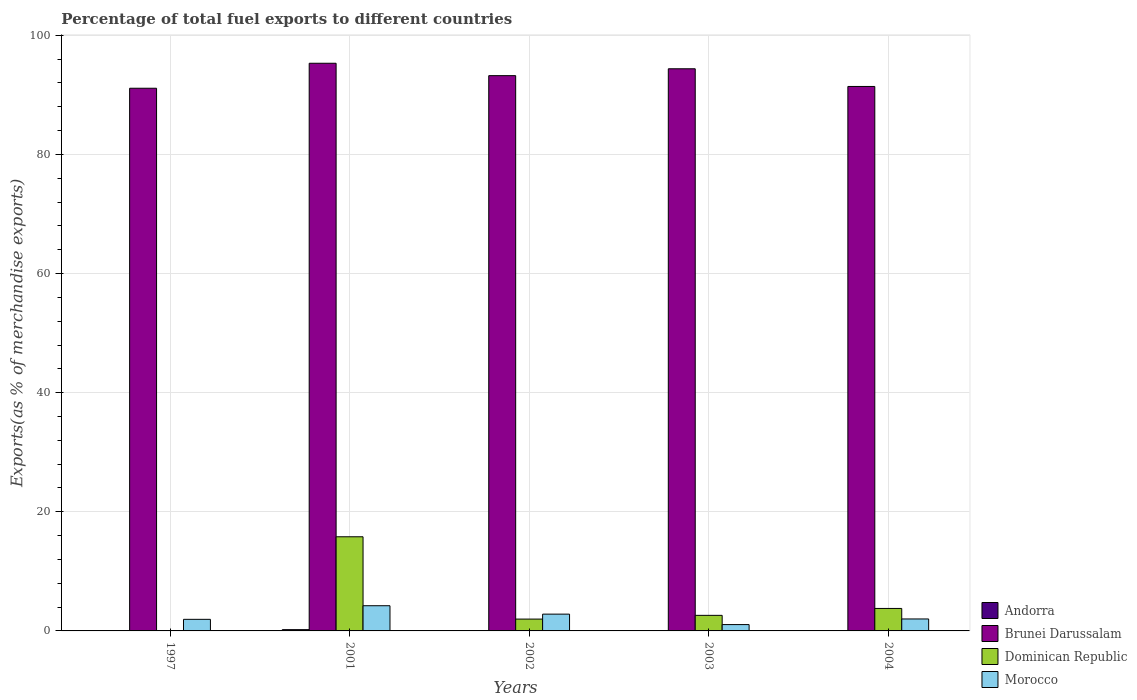How many different coloured bars are there?
Your answer should be compact. 4. Are the number of bars per tick equal to the number of legend labels?
Give a very brief answer. Yes. How many bars are there on the 4th tick from the left?
Your answer should be compact. 4. How many bars are there on the 1st tick from the right?
Your answer should be very brief. 4. What is the label of the 1st group of bars from the left?
Your answer should be very brief. 1997. What is the percentage of exports to different countries in Brunei Darussalam in 2002?
Keep it short and to the point. 93.23. Across all years, what is the maximum percentage of exports to different countries in Morocco?
Your answer should be very brief. 4.23. Across all years, what is the minimum percentage of exports to different countries in Andorra?
Your answer should be very brief. 0. In which year was the percentage of exports to different countries in Brunei Darussalam maximum?
Your response must be concise. 2001. What is the total percentage of exports to different countries in Morocco in the graph?
Your answer should be compact. 12.06. What is the difference between the percentage of exports to different countries in Andorra in 2001 and that in 2003?
Give a very brief answer. 0.21. What is the difference between the percentage of exports to different countries in Morocco in 1997 and the percentage of exports to different countries in Andorra in 2002?
Provide a short and direct response. 1.94. What is the average percentage of exports to different countries in Dominican Republic per year?
Your response must be concise. 4.84. In the year 2003, what is the difference between the percentage of exports to different countries in Andorra and percentage of exports to different countries in Dominican Republic?
Keep it short and to the point. -2.61. What is the ratio of the percentage of exports to different countries in Morocco in 2001 to that in 2004?
Your answer should be compact. 2.11. Is the percentage of exports to different countries in Morocco in 2001 less than that in 2002?
Ensure brevity in your answer.  No. Is the difference between the percentage of exports to different countries in Andorra in 2003 and 2004 greater than the difference between the percentage of exports to different countries in Dominican Republic in 2003 and 2004?
Your response must be concise. Yes. What is the difference between the highest and the second highest percentage of exports to different countries in Brunei Darussalam?
Make the answer very short. 0.92. What is the difference between the highest and the lowest percentage of exports to different countries in Dominican Republic?
Provide a succinct answer. 15.79. In how many years, is the percentage of exports to different countries in Andorra greater than the average percentage of exports to different countries in Andorra taken over all years?
Offer a very short reply. 1. Is it the case that in every year, the sum of the percentage of exports to different countries in Andorra and percentage of exports to different countries in Dominican Republic is greater than the sum of percentage of exports to different countries in Brunei Darussalam and percentage of exports to different countries in Morocco?
Keep it short and to the point. No. What does the 2nd bar from the left in 2002 represents?
Provide a short and direct response. Brunei Darussalam. What does the 4th bar from the right in 2004 represents?
Provide a short and direct response. Andorra. How many years are there in the graph?
Your response must be concise. 5. What is the difference between two consecutive major ticks on the Y-axis?
Ensure brevity in your answer.  20. Are the values on the major ticks of Y-axis written in scientific E-notation?
Provide a succinct answer. No. Does the graph contain any zero values?
Your answer should be compact. No. Does the graph contain grids?
Your response must be concise. Yes. Where does the legend appear in the graph?
Offer a very short reply. Bottom right. What is the title of the graph?
Give a very brief answer. Percentage of total fuel exports to different countries. What is the label or title of the X-axis?
Give a very brief answer. Years. What is the label or title of the Y-axis?
Your answer should be compact. Exports(as % of merchandise exports). What is the Exports(as % of merchandise exports) of Andorra in 1997?
Offer a very short reply. 0.01. What is the Exports(as % of merchandise exports) in Brunei Darussalam in 1997?
Offer a terse response. 91.11. What is the Exports(as % of merchandise exports) in Dominican Republic in 1997?
Ensure brevity in your answer.  0.02. What is the Exports(as % of merchandise exports) in Morocco in 1997?
Make the answer very short. 1.94. What is the Exports(as % of merchandise exports) in Andorra in 2001?
Provide a succinct answer. 0.21. What is the Exports(as % of merchandise exports) of Brunei Darussalam in 2001?
Make the answer very short. 95.31. What is the Exports(as % of merchandise exports) in Dominican Republic in 2001?
Give a very brief answer. 15.81. What is the Exports(as % of merchandise exports) in Morocco in 2001?
Offer a terse response. 4.23. What is the Exports(as % of merchandise exports) in Andorra in 2002?
Make the answer very short. 0. What is the Exports(as % of merchandise exports) of Brunei Darussalam in 2002?
Ensure brevity in your answer.  93.23. What is the Exports(as % of merchandise exports) in Dominican Republic in 2002?
Ensure brevity in your answer.  1.99. What is the Exports(as % of merchandise exports) of Morocco in 2002?
Provide a succinct answer. 2.82. What is the Exports(as % of merchandise exports) of Andorra in 2003?
Ensure brevity in your answer.  0.01. What is the Exports(as % of merchandise exports) of Brunei Darussalam in 2003?
Make the answer very short. 94.38. What is the Exports(as % of merchandise exports) of Dominican Republic in 2003?
Your answer should be compact. 2.61. What is the Exports(as % of merchandise exports) in Morocco in 2003?
Provide a succinct answer. 1.06. What is the Exports(as % of merchandise exports) in Andorra in 2004?
Your answer should be very brief. 0. What is the Exports(as % of merchandise exports) of Brunei Darussalam in 2004?
Keep it short and to the point. 91.41. What is the Exports(as % of merchandise exports) of Dominican Republic in 2004?
Make the answer very short. 3.77. What is the Exports(as % of merchandise exports) of Morocco in 2004?
Provide a short and direct response. 2.01. Across all years, what is the maximum Exports(as % of merchandise exports) in Andorra?
Your answer should be compact. 0.21. Across all years, what is the maximum Exports(as % of merchandise exports) of Brunei Darussalam?
Keep it short and to the point. 95.31. Across all years, what is the maximum Exports(as % of merchandise exports) in Dominican Republic?
Give a very brief answer. 15.81. Across all years, what is the maximum Exports(as % of merchandise exports) of Morocco?
Make the answer very short. 4.23. Across all years, what is the minimum Exports(as % of merchandise exports) in Andorra?
Provide a succinct answer. 0. Across all years, what is the minimum Exports(as % of merchandise exports) in Brunei Darussalam?
Make the answer very short. 91.11. Across all years, what is the minimum Exports(as % of merchandise exports) of Dominican Republic?
Offer a terse response. 0.02. Across all years, what is the minimum Exports(as % of merchandise exports) of Morocco?
Your response must be concise. 1.06. What is the total Exports(as % of merchandise exports) in Andorra in the graph?
Your response must be concise. 0.23. What is the total Exports(as % of merchandise exports) in Brunei Darussalam in the graph?
Provide a short and direct response. 465.43. What is the total Exports(as % of merchandise exports) of Dominican Republic in the graph?
Your answer should be very brief. 24.2. What is the total Exports(as % of merchandise exports) in Morocco in the graph?
Keep it short and to the point. 12.06. What is the difference between the Exports(as % of merchandise exports) in Andorra in 1997 and that in 2001?
Offer a very short reply. -0.21. What is the difference between the Exports(as % of merchandise exports) in Brunei Darussalam in 1997 and that in 2001?
Give a very brief answer. -4.19. What is the difference between the Exports(as % of merchandise exports) in Dominican Republic in 1997 and that in 2001?
Offer a terse response. -15.79. What is the difference between the Exports(as % of merchandise exports) of Morocco in 1997 and that in 2001?
Make the answer very short. -2.29. What is the difference between the Exports(as % of merchandise exports) in Andorra in 1997 and that in 2002?
Ensure brevity in your answer.  0. What is the difference between the Exports(as % of merchandise exports) of Brunei Darussalam in 1997 and that in 2002?
Provide a short and direct response. -2.11. What is the difference between the Exports(as % of merchandise exports) in Dominican Republic in 1997 and that in 2002?
Provide a succinct answer. -1.96. What is the difference between the Exports(as % of merchandise exports) in Morocco in 1997 and that in 2002?
Provide a short and direct response. -0.87. What is the difference between the Exports(as % of merchandise exports) in Andorra in 1997 and that in 2003?
Provide a succinct answer. -0. What is the difference between the Exports(as % of merchandise exports) of Brunei Darussalam in 1997 and that in 2003?
Your answer should be compact. -3.27. What is the difference between the Exports(as % of merchandise exports) in Dominican Republic in 1997 and that in 2003?
Your answer should be compact. -2.59. What is the difference between the Exports(as % of merchandise exports) of Morocco in 1997 and that in 2003?
Offer a terse response. 0.88. What is the difference between the Exports(as % of merchandise exports) in Andorra in 1997 and that in 2004?
Offer a terse response. 0. What is the difference between the Exports(as % of merchandise exports) of Brunei Darussalam in 1997 and that in 2004?
Offer a very short reply. -0.3. What is the difference between the Exports(as % of merchandise exports) of Dominican Republic in 1997 and that in 2004?
Your answer should be compact. -3.75. What is the difference between the Exports(as % of merchandise exports) in Morocco in 1997 and that in 2004?
Give a very brief answer. -0.06. What is the difference between the Exports(as % of merchandise exports) in Andorra in 2001 and that in 2002?
Your answer should be compact. 0.21. What is the difference between the Exports(as % of merchandise exports) of Brunei Darussalam in 2001 and that in 2002?
Give a very brief answer. 2.08. What is the difference between the Exports(as % of merchandise exports) of Dominican Republic in 2001 and that in 2002?
Give a very brief answer. 13.82. What is the difference between the Exports(as % of merchandise exports) of Morocco in 2001 and that in 2002?
Give a very brief answer. 1.41. What is the difference between the Exports(as % of merchandise exports) in Andorra in 2001 and that in 2003?
Keep it short and to the point. 0.21. What is the difference between the Exports(as % of merchandise exports) in Brunei Darussalam in 2001 and that in 2003?
Your response must be concise. 0.92. What is the difference between the Exports(as % of merchandise exports) in Dominican Republic in 2001 and that in 2003?
Your answer should be very brief. 13.19. What is the difference between the Exports(as % of merchandise exports) of Morocco in 2001 and that in 2003?
Ensure brevity in your answer.  3.17. What is the difference between the Exports(as % of merchandise exports) in Andorra in 2001 and that in 2004?
Provide a succinct answer. 0.21. What is the difference between the Exports(as % of merchandise exports) of Brunei Darussalam in 2001 and that in 2004?
Make the answer very short. 3.9. What is the difference between the Exports(as % of merchandise exports) of Dominican Republic in 2001 and that in 2004?
Provide a short and direct response. 12.03. What is the difference between the Exports(as % of merchandise exports) of Morocco in 2001 and that in 2004?
Your answer should be compact. 2.22. What is the difference between the Exports(as % of merchandise exports) in Andorra in 2002 and that in 2003?
Offer a terse response. -0. What is the difference between the Exports(as % of merchandise exports) in Brunei Darussalam in 2002 and that in 2003?
Provide a succinct answer. -1.16. What is the difference between the Exports(as % of merchandise exports) of Dominican Republic in 2002 and that in 2003?
Give a very brief answer. -0.63. What is the difference between the Exports(as % of merchandise exports) of Morocco in 2002 and that in 2003?
Your answer should be compact. 1.76. What is the difference between the Exports(as % of merchandise exports) in Andorra in 2002 and that in 2004?
Your answer should be compact. 0. What is the difference between the Exports(as % of merchandise exports) of Brunei Darussalam in 2002 and that in 2004?
Give a very brief answer. 1.82. What is the difference between the Exports(as % of merchandise exports) of Dominican Republic in 2002 and that in 2004?
Provide a short and direct response. -1.79. What is the difference between the Exports(as % of merchandise exports) in Morocco in 2002 and that in 2004?
Ensure brevity in your answer.  0.81. What is the difference between the Exports(as % of merchandise exports) in Andorra in 2003 and that in 2004?
Your response must be concise. 0. What is the difference between the Exports(as % of merchandise exports) of Brunei Darussalam in 2003 and that in 2004?
Provide a short and direct response. 2.97. What is the difference between the Exports(as % of merchandise exports) in Dominican Republic in 2003 and that in 2004?
Give a very brief answer. -1.16. What is the difference between the Exports(as % of merchandise exports) in Morocco in 2003 and that in 2004?
Give a very brief answer. -0.95. What is the difference between the Exports(as % of merchandise exports) of Andorra in 1997 and the Exports(as % of merchandise exports) of Brunei Darussalam in 2001?
Your answer should be compact. -95.3. What is the difference between the Exports(as % of merchandise exports) of Andorra in 1997 and the Exports(as % of merchandise exports) of Dominican Republic in 2001?
Give a very brief answer. -15.8. What is the difference between the Exports(as % of merchandise exports) in Andorra in 1997 and the Exports(as % of merchandise exports) in Morocco in 2001?
Make the answer very short. -4.22. What is the difference between the Exports(as % of merchandise exports) in Brunei Darussalam in 1997 and the Exports(as % of merchandise exports) in Dominican Republic in 2001?
Offer a very short reply. 75.3. What is the difference between the Exports(as % of merchandise exports) of Brunei Darussalam in 1997 and the Exports(as % of merchandise exports) of Morocco in 2001?
Make the answer very short. 86.88. What is the difference between the Exports(as % of merchandise exports) in Dominican Republic in 1997 and the Exports(as % of merchandise exports) in Morocco in 2001?
Ensure brevity in your answer.  -4.21. What is the difference between the Exports(as % of merchandise exports) in Andorra in 1997 and the Exports(as % of merchandise exports) in Brunei Darussalam in 2002?
Offer a terse response. -93.22. What is the difference between the Exports(as % of merchandise exports) of Andorra in 1997 and the Exports(as % of merchandise exports) of Dominican Republic in 2002?
Give a very brief answer. -1.98. What is the difference between the Exports(as % of merchandise exports) of Andorra in 1997 and the Exports(as % of merchandise exports) of Morocco in 2002?
Your response must be concise. -2.81. What is the difference between the Exports(as % of merchandise exports) of Brunei Darussalam in 1997 and the Exports(as % of merchandise exports) of Dominican Republic in 2002?
Provide a succinct answer. 89.12. What is the difference between the Exports(as % of merchandise exports) of Brunei Darussalam in 1997 and the Exports(as % of merchandise exports) of Morocco in 2002?
Provide a short and direct response. 88.29. What is the difference between the Exports(as % of merchandise exports) in Dominican Republic in 1997 and the Exports(as % of merchandise exports) in Morocco in 2002?
Your answer should be very brief. -2.8. What is the difference between the Exports(as % of merchandise exports) of Andorra in 1997 and the Exports(as % of merchandise exports) of Brunei Darussalam in 2003?
Your response must be concise. -94.38. What is the difference between the Exports(as % of merchandise exports) of Andorra in 1997 and the Exports(as % of merchandise exports) of Dominican Republic in 2003?
Your answer should be very brief. -2.61. What is the difference between the Exports(as % of merchandise exports) in Andorra in 1997 and the Exports(as % of merchandise exports) in Morocco in 2003?
Offer a terse response. -1.06. What is the difference between the Exports(as % of merchandise exports) of Brunei Darussalam in 1997 and the Exports(as % of merchandise exports) of Dominican Republic in 2003?
Keep it short and to the point. 88.5. What is the difference between the Exports(as % of merchandise exports) of Brunei Darussalam in 1997 and the Exports(as % of merchandise exports) of Morocco in 2003?
Your answer should be compact. 90.05. What is the difference between the Exports(as % of merchandise exports) of Dominican Republic in 1997 and the Exports(as % of merchandise exports) of Morocco in 2003?
Your answer should be compact. -1.04. What is the difference between the Exports(as % of merchandise exports) of Andorra in 1997 and the Exports(as % of merchandise exports) of Brunei Darussalam in 2004?
Ensure brevity in your answer.  -91.4. What is the difference between the Exports(as % of merchandise exports) of Andorra in 1997 and the Exports(as % of merchandise exports) of Dominican Republic in 2004?
Give a very brief answer. -3.77. What is the difference between the Exports(as % of merchandise exports) in Andorra in 1997 and the Exports(as % of merchandise exports) in Morocco in 2004?
Keep it short and to the point. -2. What is the difference between the Exports(as % of merchandise exports) in Brunei Darussalam in 1997 and the Exports(as % of merchandise exports) in Dominican Republic in 2004?
Make the answer very short. 87.34. What is the difference between the Exports(as % of merchandise exports) in Brunei Darussalam in 1997 and the Exports(as % of merchandise exports) in Morocco in 2004?
Provide a succinct answer. 89.1. What is the difference between the Exports(as % of merchandise exports) in Dominican Republic in 1997 and the Exports(as % of merchandise exports) in Morocco in 2004?
Your response must be concise. -1.99. What is the difference between the Exports(as % of merchandise exports) in Andorra in 2001 and the Exports(as % of merchandise exports) in Brunei Darussalam in 2002?
Your response must be concise. -93.01. What is the difference between the Exports(as % of merchandise exports) in Andorra in 2001 and the Exports(as % of merchandise exports) in Dominican Republic in 2002?
Offer a terse response. -1.77. What is the difference between the Exports(as % of merchandise exports) of Andorra in 2001 and the Exports(as % of merchandise exports) of Morocco in 2002?
Offer a terse response. -2.61. What is the difference between the Exports(as % of merchandise exports) in Brunei Darussalam in 2001 and the Exports(as % of merchandise exports) in Dominican Republic in 2002?
Offer a very short reply. 93.32. What is the difference between the Exports(as % of merchandise exports) in Brunei Darussalam in 2001 and the Exports(as % of merchandise exports) in Morocco in 2002?
Make the answer very short. 92.49. What is the difference between the Exports(as % of merchandise exports) in Dominican Republic in 2001 and the Exports(as % of merchandise exports) in Morocco in 2002?
Your response must be concise. 12.99. What is the difference between the Exports(as % of merchandise exports) in Andorra in 2001 and the Exports(as % of merchandise exports) in Brunei Darussalam in 2003?
Provide a succinct answer. -94.17. What is the difference between the Exports(as % of merchandise exports) in Andorra in 2001 and the Exports(as % of merchandise exports) in Dominican Republic in 2003?
Keep it short and to the point. -2.4. What is the difference between the Exports(as % of merchandise exports) in Andorra in 2001 and the Exports(as % of merchandise exports) in Morocco in 2003?
Provide a short and direct response. -0.85. What is the difference between the Exports(as % of merchandise exports) of Brunei Darussalam in 2001 and the Exports(as % of merchandise exports) of Dominican Republic in 2003?
Keep it short and to the point. 92.69. What is the difference between the Exports(as % of merchandise exports) of Brunei Darussalam in 2001 and the Exports(as % of merchandise exports) of Morocco in 2003?
Your response must be concise. 94.24. What is the difference between the Exports(as % of merchandise exports) in Dominican Republic in 2001 and the Exports(as % of merchandise exports) in Morocco in 2003?
Your answer should be compact. 14.74. What is the difference between the Exports(as % of merchandise exports) in Andorra in 2001 and the Exports(as % of merchandise exports) in Brunei Darussalam in 2004?
Ensure brevity in your answer.  -91.2. What is the difference between the Exports(as % of merchandise exports) in Andorra in 2001 and the Exports(as % of merchandise exports) in Dominican Republic in 2004?
Your answer should be very brief. -3.56. What is the difference between the Exports(as % of merchandise exports) of Andorra in 2001 and the Exports(as % of merchandise exports) of Morocco in 2004?
Provide a short and direct response. -1.8. What is the difference between the Exports(as % of merchandise exports) of Brunei Darussalam in 2001 and the Exports(as % of merchandise exports) of Dominican Republic in 2004?
Your response must be concise. 91.53. What is the difference between the Exports(as % of merchandise exports) in Brunei Darussalam in 2001 and the Exports(as % of merchandise exports) in Morocco in 2004?
Your answer should be compact. 93.3. What is the difference between the Exports(as % of merchandise exports) in Dominican Republic in 2001 and the Exports(as % of merchandise exports) in Morocco in 2004?
Offer a terse response. 13.8. What is the difference between the Exports(as % of merchandise exports) of Andorra in 2002 and the Exports(as % of merchandise exports) of Brunei Darussalam in 2003?
Give a very brief answer. -94.38. What is the difference between the Exports(as % of merchandise exports) of Andorra in 2002 and the Exports(as % of merchandise exports) of Dominican Republic in 2003?
Offer a very short reply. -2.61. What is the difference between the Exports(as % of merchandise exports) in Andorra in 2002 and the Exports(as % of merchandise exports) in Morocco in 2003?
Offer a very short reply. -1.06. What is the difference between the Exports(as % of merchandise exports) of Brunei Darussalam in 2002 and the Exports(as % of merchandise exports) of Dominican Republic in 2003?
Provide a short and direct response. 90.61. What is the difference between the Exports(as % of merchandise exports) in Brunei Darussalam in 2002 and the Exports(as % of merchandise exports) in Morocco in 2003?
Your response must be concise. 92.16. What is the difference between the Exports(as % of merchandise exports) of Dominican Republic in 2002 and the Exports(as % of merchandise exports) of Morocco in 2003?
Offer a terse response. 0.92. What is the difference between the Exports(as % of merchandise exports) of Andorra in 2002 and the Exports(as % of merchandise exports) of Brunei Darussalam in 2004?
Provide a short and direct response. -91.41. What is the difference between the Exports(as % of merchandise exports) of Andorra in 2002 and the Exports(as % of merchandise exports) of Dominican Republic in 2004?
Your response must be concise. -3.77. What is the difference between the Exports(as % of merchandise exports) in Andorra in 2002 and the Exports(as % of merchandise exports) in Morocco in 2004?
Offer a very short reply. -2.01. What is the difference between the Exports(as % of merchandise exports) of Brunei Darussalam in 2002 and the Exports(as % of merchandise exports) of Dominican Republic in 2004?
Your answer should be compact. 89.45. What is the difference between the Exports(as % of merchandise exports) in Brunei Darussalam in 2002 and the Exports(as % of merchandise exports) in Morocco in 2004?
Offer a very short reply. 91.22. What is the difference between the Exports(as % of merchandise exports) in Dominican Republic in 2002 and the Exports(as % of merchandise exports) in Morocco in 2004?
Make the answer very short. -0.02. What is the difference between the Exports(as % of merchandise exports) in Andorra in 2003 and the Exports(as % of merchandise exports) in Brunei Darussalam in 2004?
Ensure brevity in your answer.  -91.4. What is the difference between the Exports(as % of merchandise exports) of Andorra in 2003 and the Exports(as % of merchandise exports) of Dominican Republic in 2004?
Offer a very short reply. -3.77. What is the difference between the Exports(as % of merchandise exports) in Andorra in 2003 and the Exports(as % of merchandise exports) in Morocco in 2004?
Provide a succinct answer. -2. What is the difference between the Exports(as % of merchandise exports) of Brunei Darussalam in 2003 and the Exports(as % of merchandise exports) of Dominican Republic in 2004?
Provide a short and direct response. 90.61. What is the difference between the Exports(as % of merchandise exports) of Brunei Darussalam in 2003 and the Exports(as % of merchandise exports) of Morocco in 2004?
Your answer should be very brief. 92.37. What is the difference between the Exports(as % of merchandise exports) in Dominican Republic in 2003 and the Exports(as % of merchandise exports) in Morocco in 2004?
Ensure brevity in your answer.  0.6. What is the average Exports(as % of merchandise exports) in Andorra per year?
Your response must be concise. 0.05. What is the average Exports(as % of merchandise exports) of Brunei Darussalam per year?
Ensure brevity in your answer.  93.09. What is the average Exports(as % of merchandise exports) of Dominican Republic per year?
Ensure brevity in your answer.  4.84. What is the average Exports(as % of merchandise exports) of Morocco per year?
Provide a succinct answer. 2.41. In the year 1997, what is the difference between the Exports(as % of merchandise exports) of Andorra and Exports(as % of merchandise exports) of Brunei Darussalam?
Ensure brevity in your answer.  -91.11. In the year 1997, what is the difference between the Exports(as % of merchandise exports) of Andorra and Exports(as % of merchandise exports) of Dominican Republic?
Provide a succinct answer. -0.02. In the year 1997, what is the difference between the Exports(as % of merchandise exports) in Andorra and Exports(as % of merchandise exports) in Morocco?
Your answer should be compact. -1.94. In the year 1997, what is the difference between the Exports(as % of merchandise exports) of Brunei Darussalam and Exports(as % of merchandise exports) of Dominican Republic?
Ensure brevity in your answer.  91.09. In the year 1997, what is the difference between the Exports(as % of merchandise exports) of Brunei Darussalam and Exports(as % of merchandise exports) of Morocco?
Make the answer very short. 89.17. In the year 1997, what is the difference between the Exports(as % of merchandise exports) in Dominican Republic and Exports(as % of merchandise exports) in Morocco?
Provide a succinct answer. -1.92. In the year 2001, what is the difference between the Exports(as % of merchandise exports) of Andorra and Exports(as % of merchandise exports) of Brunei Darussalam?
Your answer should be very brief. -95.09. In the year 2001, what is the difference between the Exports(as % of merchandise exports) of Andorra and Exports(as % of merchandise exports) of Dominican Republic?
Provide a short and direct response. -15.59. In the year 2001, what is the difference between the Exports(as % of merchandise exports) of Andorra and Exports(as % of merchandise exports) of Morocco?
Provide a succinct answer. -4.02. In the year 2001, what is the difference between the Exports(as % of merchandise exports) in Brunei Darussalam and Exports(as % of merchandise exports) in Dominican Republic?
Keep it short and to the point. 79.5. In the year 2001, what is the difference between the Exports(as % of merchandise exports) in Brunei Darussalam and Exports(as % of merchandise exports) in Morocco?
Provide a short and direct response. 91.08. In the year 2001, what is the difference between the Exports(as % of merchandise exports) of Dominican Republic and Exports(as % of merchandise exports) of Morocco?
Your response must be concise. 11.58. In the year 2002, what is the difference between the Exports(as % of merchandise exports) of Andorra and Exports(as % of merchandise exports) of Brunei Darussalam?
Provide a short and direct response. -93.22. In the year 2002, what is the difference between the Exports(as % of merchandise exports) in Andorra and Exports(as % of merchandise exports) in Dominican Republic?
Offer a terse response. -1.98. In the year 2002, what is the difference between the Exports(as % of merchandise exports) of Andorra and Exports(as % of merchandise exports) of Morocco?
Give a very brief answer. -2.82. In the year 2002, what is the difference between the Exports(as % of merchandise exports) in Brunei Darussalam and Exports(as % of merchandise exports) in Dominican Republic?
Provide a succinct answer. 91.24. In the year 2002, what is the difference between the Exports(as % of merchandise exports) of Brunei Darussalam and Exports(as % of merchandise exports) of Morocco?
Offer a terse response. 90.41. In the year 2002, what is the difference between the Exports(as % of merchandise exports) in Dominican Republic and Exports(as % of merchandise exports) in Morocco?
Give a very brief answer. -0.83. In the year 2003, what is the difference between the Exports(as % of merchandise exports) of Andorra and Exports(as % of merchandise exports) of Brunei Darussalam?
Keep it short and to the point. -94.37. In the year 2003, what is the difference between the Exports(as % of merchandise exports) of Andorra and Exports(as % of merchandise exports) of Dominican Republic?
Offer a terse response. -2.61. In the year 2003, what is the difference between the Exports(as % of merchandise exports) of Andorra and Exports(as % of merchandise exports) of Morocco?
Provide a succinct answer. -1.06. In the year 2003, what is the difference between the Exports(as % of merchandise exports) in Brunei Darussalam and Exports(as % of merchandise exports) in Dominican Republic?
Give a very brief answer. 91.77. In the year 2003, what is the difference between the Exports(as % of merchandise exports) in Brunei Darussalam and Exports(as % of merchandise exports) in Morocco?
Offer a very short reply. 93.32. In the year 2003, what is the difference between the Exports(as % of merchandise exports) in Dominican Republic and Exports(as % of merchandise exports) in Morocco?
Offer a very short reply. 1.55. In the year 2004, what is the difference between the Exports(as % of merchandise exports) in Andorra and Exports(as % of merchandise exports) in Brunei Darussalam?
Your answer should be compact. -91.41. In the year 2004, what is the difference between the Exports(as % of merchandise exports) of Andorra and Exports(as % of merchandise exports) of Dominican Republic?
Offer a terse response. -3.77. In the year 2004, what is the difference between the Exports(as % of merchandise exports) of Andorra and Exports(as % of merchandise exports) of Morocco?
Offer a terse response. -2.01. In the year 2004, what is the difference between the Exports(as % of merchandise exports) in Brunei Darussalam and Exports(as % of merchandise exports) in Dominican Republic?
Ensure brevity in your answer.  87.64. In the year 2004, what is the difference between the Exports(as % of merchandise exports) in Brunei Darussalam and Exports(as % of merchandise exports) in Morocco?
Ensure brevity in your answer.  89.4. In the year 2004, what is the difference between the Exports(as % of merchandise exports) in Dominican Republic and Exports(as % of merchandise exports) in Morocco?
Provide a succinct answer. 1.76. What is the ratio of the Exports(as % of merchandise exports) of Andorra in 1997 to that in 2001?
Offer a very short reply. 0.03. What is the ratio of the Exports(as % of merchandise exports) in Brunei Darussalam in 1997 to that in 2001?
Offer a very short reply. 0.96. What is the ratio of the Exports(as % of merchandise exports) of Dominican Republic in 1997 to that in 2001?
Make the answer very short. 0. What is the ratio of the Exports(as % of merchandise exports) of Morocco in 1997 to that in 2001?
Offer a very short reply. 0.46. What is the ratio of the Exports(as % of merchandise exports) in Andorra in 1997 to that in 2002?
Offer a very short reply. 1.8. What is the ratio of the Exports(as % of merchandise exports) of Brunei Darussalam in 1997 to that in 2002?
Make the answer very short. 0.98. What is the ratio of the Exports(as % of merchandise exports) in Dominican Republic in 1997 to that in 2002?
Provide a succinct answer. 0.01. What is the ratio of the Exports(as % of merchandise exports) of Morocco in 1997 to that in 2002?
Offer a very short reply. 0.69. What is the ratio of the Exports(as % of merchandise exports) of Andorra in 1997 to that in 2003?
Your answer should be compact. 0.93. What is the ratio of the Exports(as % of merchandise exports) of Brunei Darussalam in 1997 to that in 2003?
Your response must be concise. 0.97. What is the ratio of the Exports(as % of merchandise exports) in Dominican Republic in 1997 to that in 2003?
Ensure brevity in your answer.  0.01. What is the ratio of the Exports(as % of merchandise exports) in Morocco in 1997 to that in 2003?
Provide a succinct answer. 1.83. What is the ratio of the Exports(as % of merchandise exports) in Andorra in 1997 to that in 2004?
Give a very brief answer. 3.1. What is the ratio of the Exports(as % of merchandise exports) of Dominican Republic in 1997 to that in 2004?
Your response must be concise. 0.01. What is the ratio of the Exports(as % of merchandise exports) in Morocco in 1997 to that in 2004?
Your answer should be compact. 0.97. What is the ratio of the Exports(as % of merchandise exports) in Andorra in 2001 to that in 2002?
Give a very brief answer. 62.48. What is the ratio of the Exports(as % of merchandise exports) of Brunei Darussalam in 2001 to that in 2002?
Make the answer very short. 1.02. What is the ratio of the Exports(as % of merchandise exports) in Dominican Republic in 2001 to that in 2002?
Provide a short and direct response. 7.96. What is the ratio of the Exports(as % of merchandise exports) of Morocco in 2001 to that in 2002?
Keep it short and to the point. 1.5. What is the ratio of the Exports(as % of merchandise exports) of Andorra in 2001 to that in 2003?
Offer a very short reply. 32.25. What is the ratio of the Exports(as % of merchandise exports) in Brunei Darussalam in 2001 to that in 2003?
Offer a very short reply. 1.01. What is the ratio of the Exports(as % of merchandise exports) of Dominican Republic in 2001 to that in 2003?
Keep it short and to the point. 6.05. What is the ratio of the Exports(as % of merchandise exports) of Morocco in 2001 to that in 2003?
Provide a short and direct response. 3.98. What is the ratio of the Exports(as % of merchandise exports) in Andorra in 2001 to that in 2004?
Your answer should be very brief. 107.62. What is the ratio of the Exports(as % of merchandise exports) in Brunei Darussalam in 2001 to that in 2004?
Your response must be concise. 1.04. What is the ratio of the Exports(as % of merchandise exports) of Dominican Republic in 2001 to that in 2004?
Offer a terse response. 4.19. What is the ratio of the Exports(as % of merchandise exports) in Morocco in 2001 to that in 2004?
Your answer should be very brief. 2.11. What is the ratio of the Exports(as % of merchandise exports) in Andorra in 2002 to that in 2003?
Offer a terse response. 0.52. What is the ratio of the Exports(as % of merchandise exports) in Dominican Republic in 2002 to that in 2003?
Your response must be concise. 0.76. What is the ratio of the Exports(as % of merchandise exports) of Morocco in 2002 to that in 2003?
Ensure brevity in your answer.  2.65. What is the ratio of the Exports(as % of merchandise exports) in Andorra in 2002 to that in 2004?
Ensure brevity in your answer.  1.72. What is the ratio of the Exports(as % of merchandise exports) in Brunei Darussalam in 2002 to that in 2004?
Offer a very short reply. 1.02. What is the ratio of the Exports(as % of merchandise exports) of Dominican Republic in 2002 to that in 2004?
Your response must be concise. 0.53. What is the ratio of the Exports(as % of merchandise exports) of Morocco in 2002 to that in 2004?
Ensure brevity in your answer.  1.4. What is the ratio of the Exports(as % of merchandise exports) of Andorra in 2003 to that in 2004?
Your answer should be very brief. 3.34. What is the ratio of the Exports(as % of merchandise exports) in Brunei Darussalam in 2003 to that in 2004?
Offer a terse response. 1.03. What is the ratio of the Exports(as % of merchandise exports) of Dominican Republic in 2003 to that in 2004?
Offer a very short reply. 0.69. What is the ratio of the Exports(as % of merchandise exports) in Morocco in 2003 to that in 2004?
Your answer should be very brief. 0.53. What is the difference between the highest and the second highest Exports(as % of merchandise exports) of Andorra?
Keep it short and to the point. 0.21. What is the difference between the highest and the second highest Exports(as % of merchandise exports) of Brunei Darussalam?
Offer a very short reply. 0.92. What is the difference between the highest and the second highest Exports(as % of merchandise exports) of Dominican Republic?
Your answer should be very brief. 12.03. What is the difference between the highest and the second highest Exports(as % of merchandise exports) of Morocco?
Ensure brevity in your answer.  1.41. What is the difference between the highest and the lowest Exports(as % of merchandise exports) of Andorra?
Your answer should be compact. 0.21. What is the difference between the highest and the lowest Exports(as % of merchandise exports) of Brunei Darussalam?
Provide a succinct answer. 4.19. What is the difference between the highest and the lowest Exports(as % of merchandise exports) in Dominican Republic?
Your answer should be compact. 15.79. What is the difference between the highest and the lowest Exports(as % of merchandise exports) of Morocco?
Offer a very short reply. 3.17. 